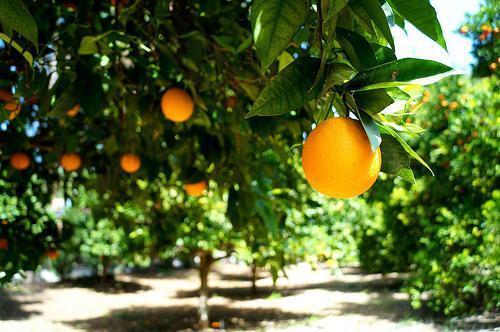How many fruits are in focus?
Give a very brief answer. 1. 